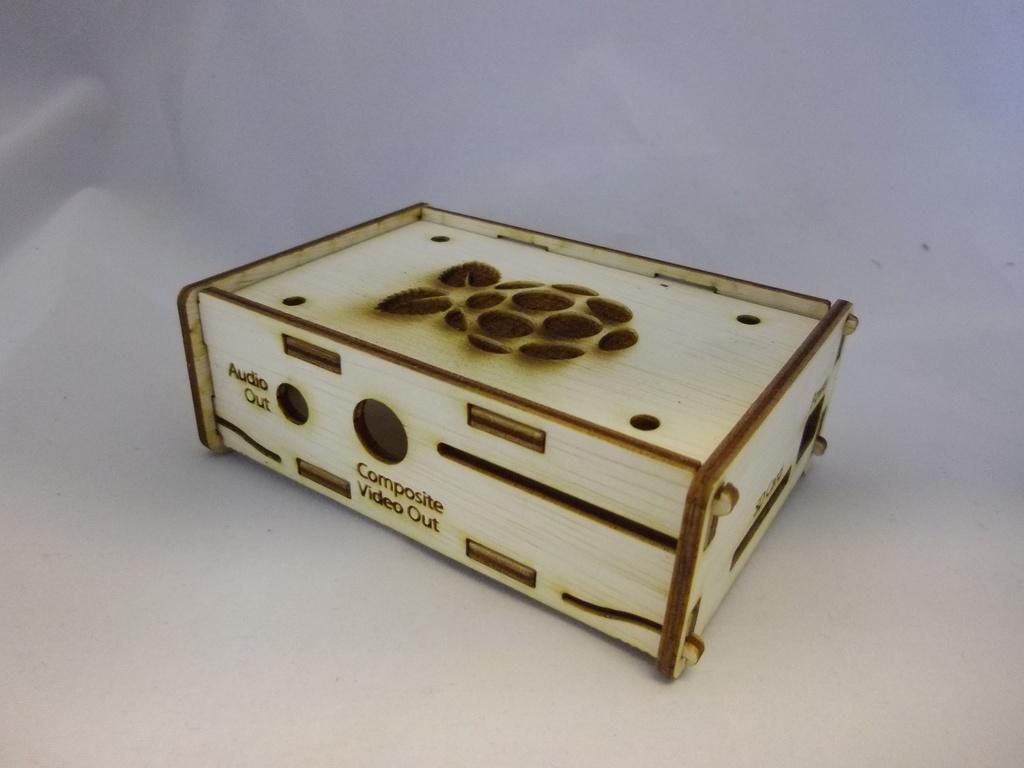What are the labels on this box?
Provide a succinct answer. Audio out, composite video out. 